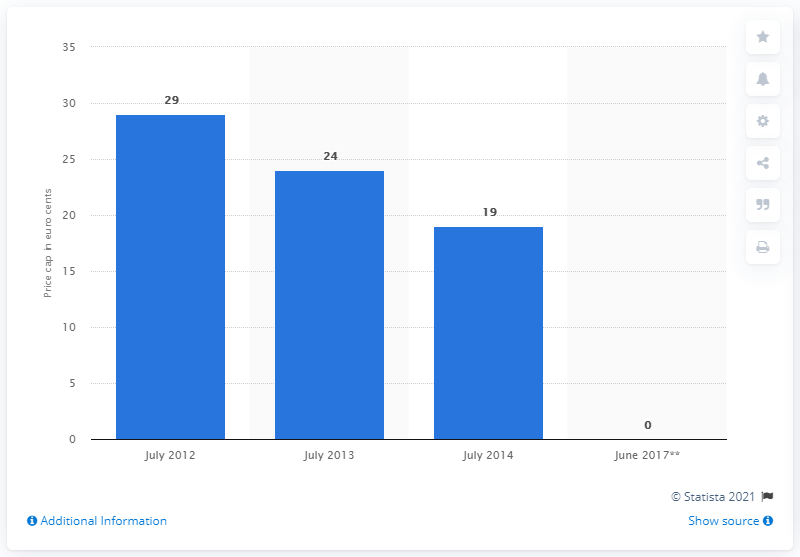Indicate a few pertinent items in this graphic. The European Commission imposed a cap on voice calls in July 2014. 